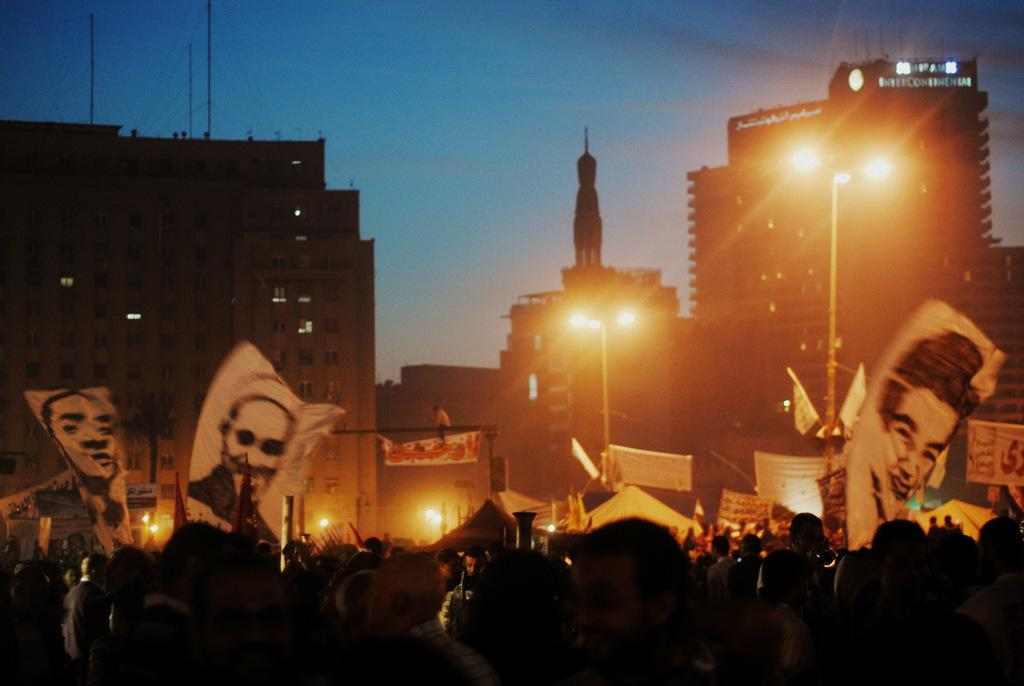What are the people in the image doing on the road? The people in the image are standing on the road and holding human pictures in their hands. What can be seen in the background of the image? There are buildings, street poles, street lights, and the sky visible in the background of the image. What type of pie is being served at the event in the image? There is no event or pie present in the image; it features people standing on the road holding human pictures. How are the people in the image connected to the match that is not visible in the image? There is no match present in the image, and the people are not connected to any match. 